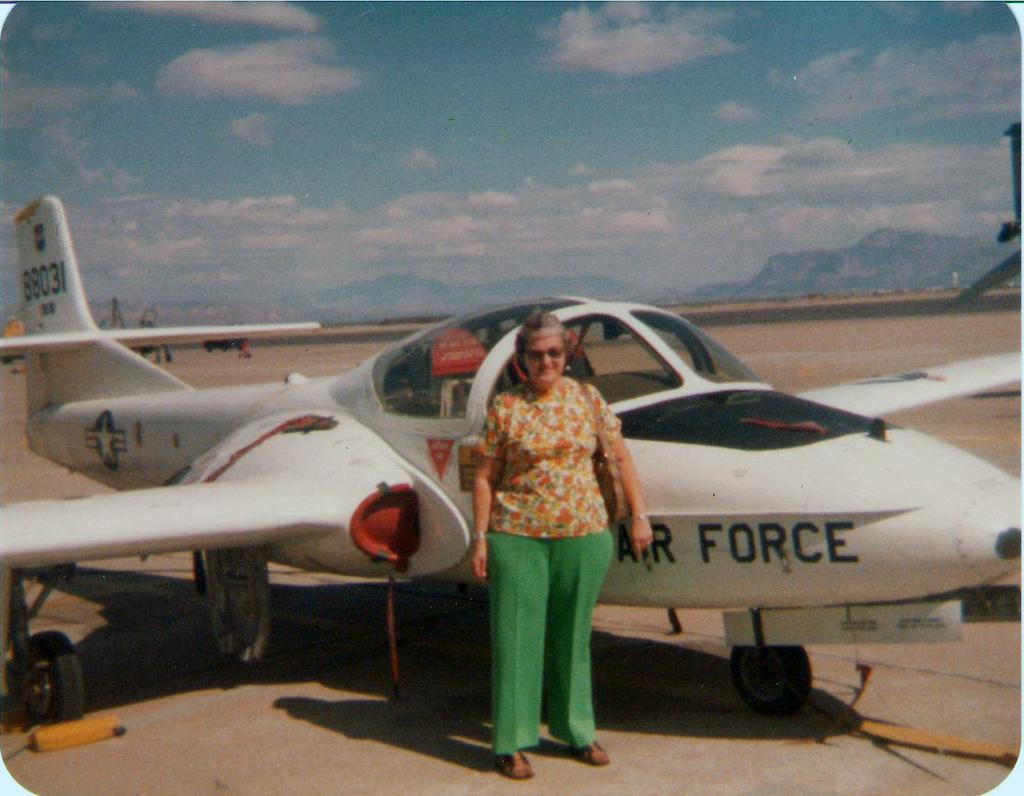<image>
Present a compact description of the photo's key features. A woman is standing next to an Air Force plane. 